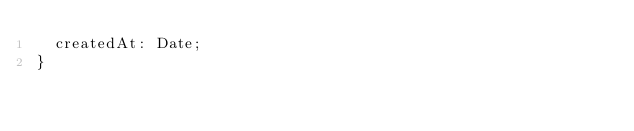<code> <loc_0><loc_0><loc_500><loc_500><_TypeScript_>  createdAt: Date;
}</code> 